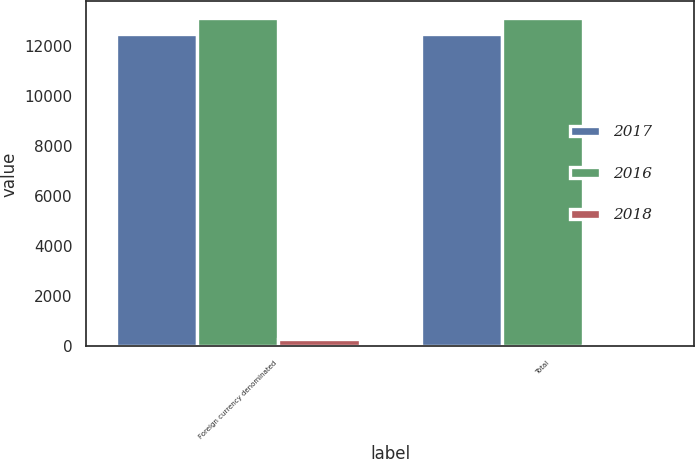Convert chart to OTSL. <chart><loc_0><loc_0><loc_500><loc_500><stacked_bar_chart><ecel><fcel>Foreign currency denominated<fcel>Total<nl><fcel>2017<fcel>12494<fcel>12494<nl><fcel>2016<fcel>13147<fcel>13147<nl><fcel>2018<fcel>304<fcel>67<nl></chart> 